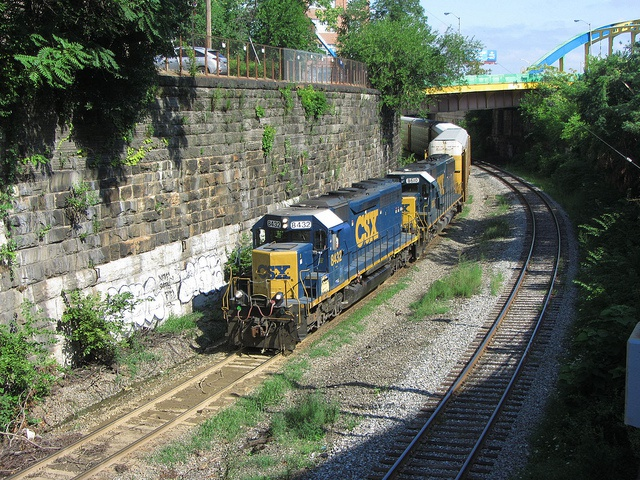Describe the objects in this image and their specific colors. I can see train in black, gray, and blue tones and car in black, gray, darkgray, and lightgray tones in this image. 